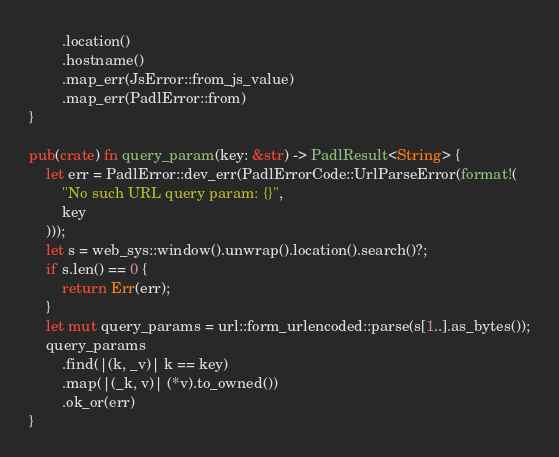Convert code to text. <code><loc_0><loc_0><loc_500><loc_500><_Rust_>        .location()
        .hostname()
        .map_err(JsError::from_js_value)
        .map_err(PadlError::from)
}

pub(crate) fn query_param(key: &str) -> PadlResult<String> {
    let err = PadlError::dev_err(PadlErrorCode::UrlParseError(format!(
        "No such URL query param: {}",
        key
    )));
    let s = web_sys::window().unwrap().location().search()?;
    if s.len() == 0 {
        return Err(err);
    }
    let mut query_params = url::form_urlencoded::parse(s[1..].as_bytes());
    query_params
        .find(|(k, _v)| k == key)
        .map(|(_k, v)| (*v).to_owned())
        .ok_or(err)
}
</code> 